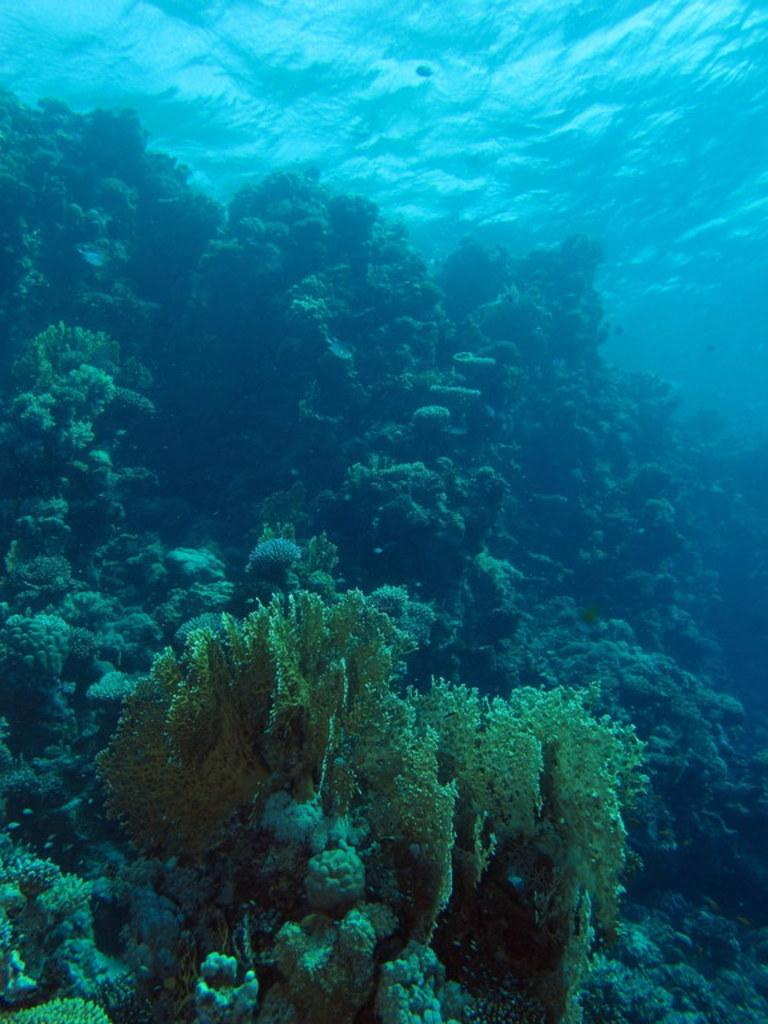What type of environment is depicted in the image? The image is an inside picture of the ocean. Are there any living organisms or objects visible in the image? Yes, there are plants visible in the image. What type of trains can be seen passing through the ocean in the image? There are no trains present in the image; it is an inside picture of the ocean with plants. Can you tell me the name of the son who is swimming with the plants in the image? There is no person, including a son, swimming with the plants in the image. 